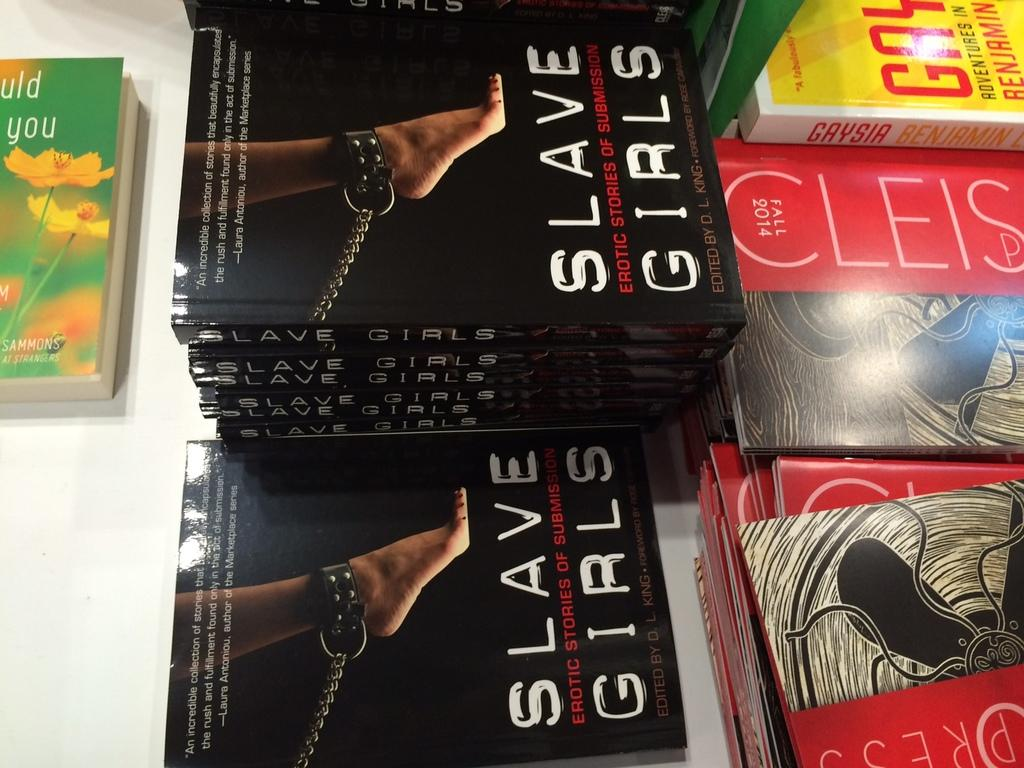<image>
Share a concise interpretation of the image provided. A stack of books titled Slave Girls sitting on a white table. 